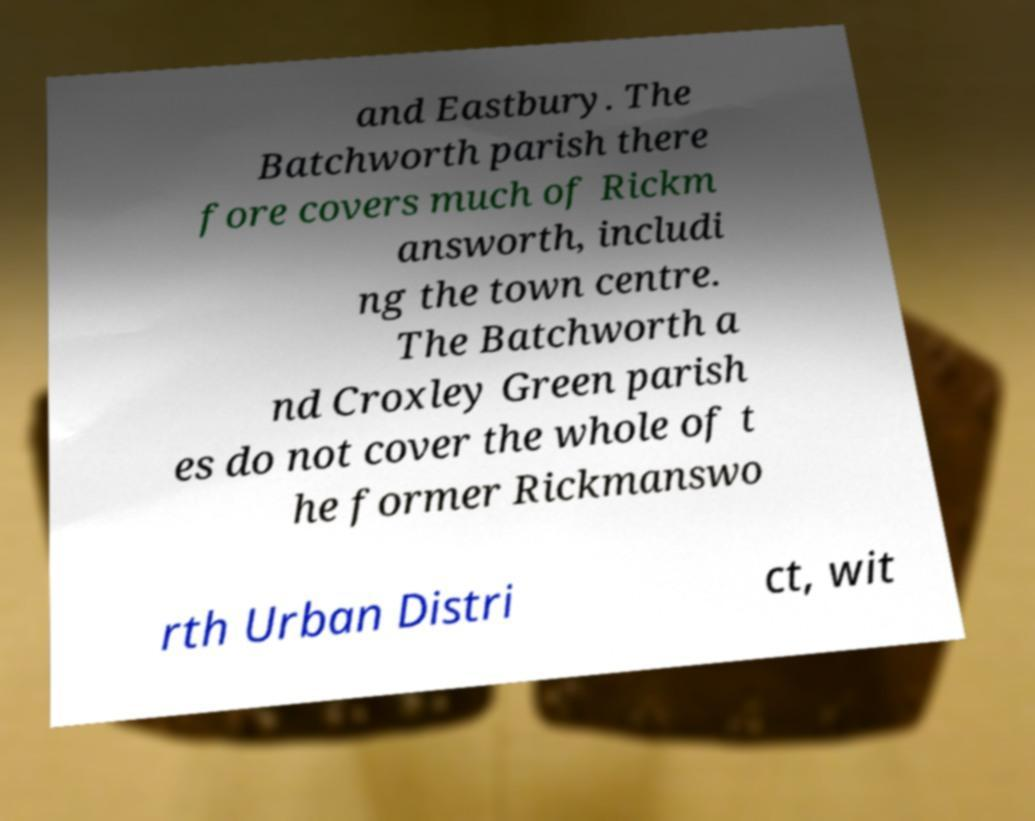For documentation purposes, I need the text within this image transcribed. Could you provide that? and Eastbury. The Batchworth parish there fore covers much of Rickm answorth, includi ng the town centre. The Batchworth a nd Croxley Green parish es do not cover the whole of t he former Rickmanswo rth Urban Distri ct, wit 